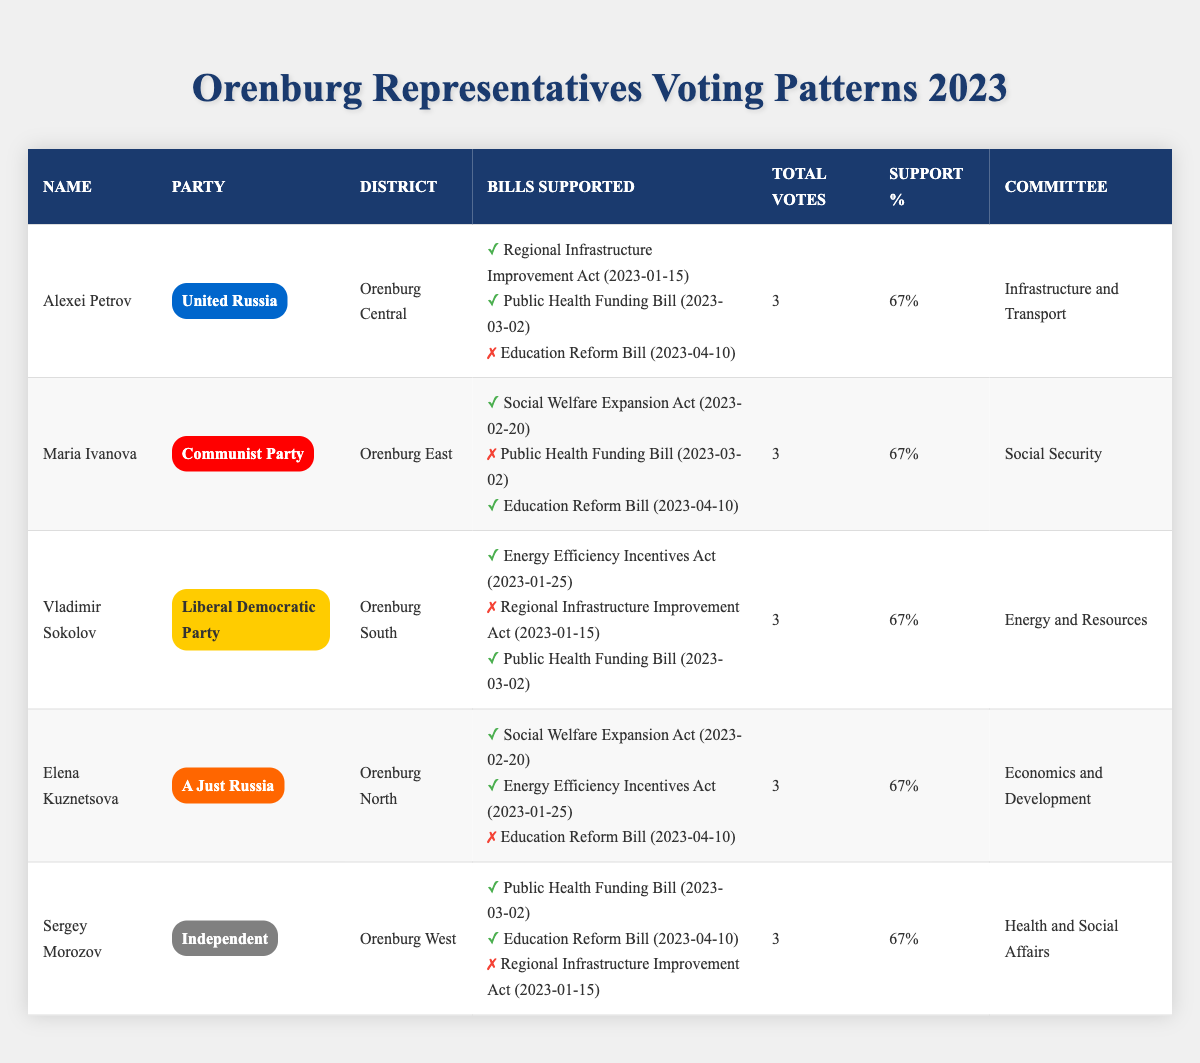What is the support percentage for Alexei Petrov? By looking at the table, Alexei Petrov has a support percentage listed as 67% in the "Support %" column.
Answer: 67% Which district does Maria Ivanova represent? The table indicates that Maria Ivanova represents the "Orenburg East" district.
Answer: Orenburg East How many total votes did Elena Kuznetsova participate in? According to the table, Elena Kuznetsova participated in a total of 3 votes, as indicated in the "Total Votes" column.
Answer: 3 Did Vladimir Sokolov vote "Yes" for the Regional Infrastructure Improvement Act? The table shows that Vladimir Sokolov voted "No" for the Regional Infrastructure Improvement Act.
Answer: No What is the name of the committee for Sergey Morozov? Sergey Morozov is a member of the "Health and Social Affairs" committee, as stated in the table.
Answer: Health and Social Affairs How many representatives supported the Education Reform Bill? The table shows that out of the 5 representatives, 2 voted "Yes" (Maria Ivanova and Sergey Morozov), and 3 voted "No." Thus, the total of those supporting the bill is 2.
Answer: 2 Is it true that all representatives have the same support percentage? Looking at the "Support %" column, all representatives listed have a support percentage of 67%, which confirms that the statement is true.
Answer: Yes What was the voting behavior of representatives for the Public Health Funding Bill? The table illustrates that Alexei Petrov, Vladimir Sokolov, Elena Kuznetsova, and Sergey Morozov all voted "Yes," while Maria Ivanova voted "No," resulting in 4 "Yes" votes and 1 "No" vote.
Answer: 4 Yes, 1 No Which representative supported the most bills? Each representative supported 2 bills while opposing 1, meaning they all equally supported the same number of bills. Thus, no specific representative stands out for supporting more bills.
Answer: None, they all supported 2 bills Calculate the average support percentage from the representatives in the table. Each representative has the same support percentage of 67%. Therefore, the average support percentage is simply 67% as it is uniform across all representatives.
Answer: 67% 